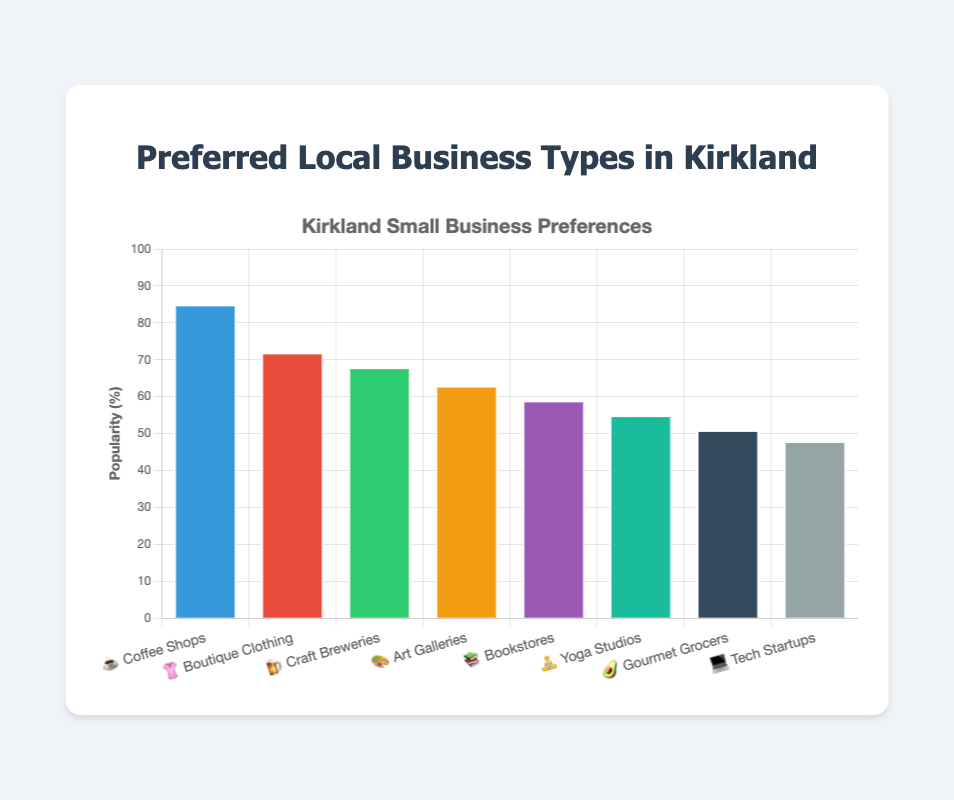Which business type has the highest popularity? The bar representing Coffee Shops (☕) is the tallest, indicating the highest popularity value of 85.
Answer: Coffee Shops How many business types have a popularity higher than 60? Four business types have popularity values greater than 60: Coffee Shops (85), Boutique Clothing (72), Craft Breweries (68), and Art Galleries (63).
Answer: 4 What is the popularity difference between the most and least popular business types? The most popular is Coffee Shops at 85 and the least popular is Tech Startups at 48, so the difference is 85 - 48.
Answer: 37 Which business type is represented by the 🥑 emoji, and what is its popularity? The 🥑 emoji represents Gourmet Grocers, and its popularity value is 51, as indicated by the bar chart labels.
Answer: Gourmet Grocers, 51 What is the average popularity of all business types? The sum of all popularity values is 85 + 72 + 68 + 63 + 59 + 55 + 51 + 48 = 501; dividing by the number of types (8) gives the average: 501 / 8.
Answer: 62.625 Among Art Galleries 🎨 and Bookstores 📚, which has a higher popularity, and by how much? Art Galleries have a popularity of 63 and Bookstores have 59, so Art Galleries are more popular by the difference 63 - 59.
Answer: Art Galleries, 4 Which business type has the least popularity, and what is its emoji? The shortest bar corresponds to Tech Startups (💻), indicating the least popularity of 48.
Answer: Tech Startups, 💻 What is the total popularity of the top three most popular business types? The three most popular are Coffee Shops (85), Boutique Clothing (72), and Craft Breweries (68). Summing these gives 85 + 72 + 68.
Answer: 225 Are there more business types with popularity values above 50 or below 50? Six business types have popularity values above 50: Coffee Shops, Boutique Clothing, Craft Breweries, Art Galleries, Bookstores, and Yoga Studios. Only Tech Startups have values below 50.
Answer: Above 50 What is the overall title of the bar chart? The title displayed prominently at the top of the chart is "Preferred Local Business Types in Kirkland".
Answer: Preferred Local Business Types in Kirkland 